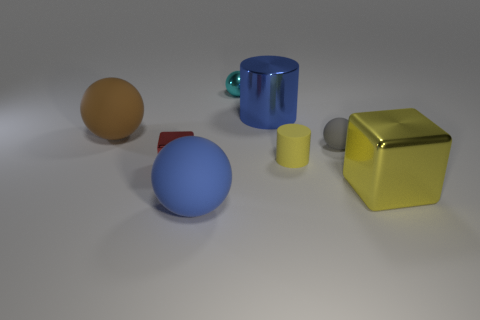Add 2 tiny gray metal balls. How many objects exist? 10 Subtract all metallic spheres. How many spheres are left? 3 Subtract 1 balls. How many balls are left? 3 Subtract all blue cylinders. Subtract all purple balls. How many cylinders are left? 1 Subtract all yellow cylinders. How many blue blocks are left? 0 Subtract all small gray rubber balls. Subtract all blue metallic objects. How many objects are left? 6 Add 6 brown rubber spheres. How many brown rubber spheres are left? 7 Add 4 purple shiny cubes. How many purple shiny cubes exist? 4 Subtract all blue cylinders. How many cylinders are left? 1 Subtract 0 cyan cylinders. How many objects are left? 8 